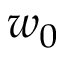<formula> <loc_0><loc_0><loc_500><loc_500>w _ { 0 }</formula> 